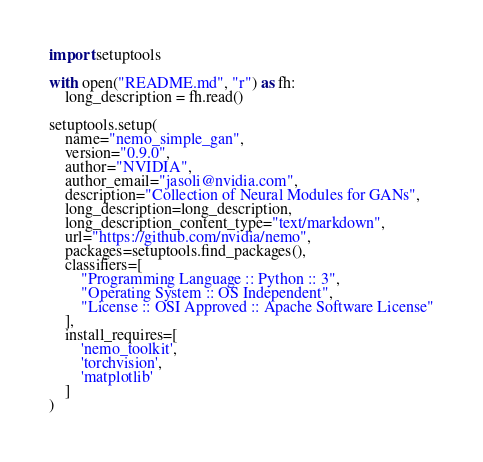<code> <loc_0><loc_0><loc_500><loc_500><_Python_>import setuptools

with open("README.md", "r") as fh:
    long_description = fh.read()

setuptools.setup(
    name="nemo_simple_gan",
    version="0.9.0",
    author="NVIDIA",
    author_email="jasoli@nvidia.com",
    description="Collection of Neural Modules for GANs",
    long_description=long_description,
    long_description_content_type="text/markdown",
    url="https://github.com/nvidia/nemo",
    packages=setuptools.find_packages(),
    classifiers=[
        "Programming Language :: Python :: 3",
        "Operating System :: OS Independent",
        "License :: OSI Approved :: Apache Software License"
    ],
    install_requires=[
        'nemo_toolkit',
        'torchvision',
        'matplotlib'
    ]
)
</code> 